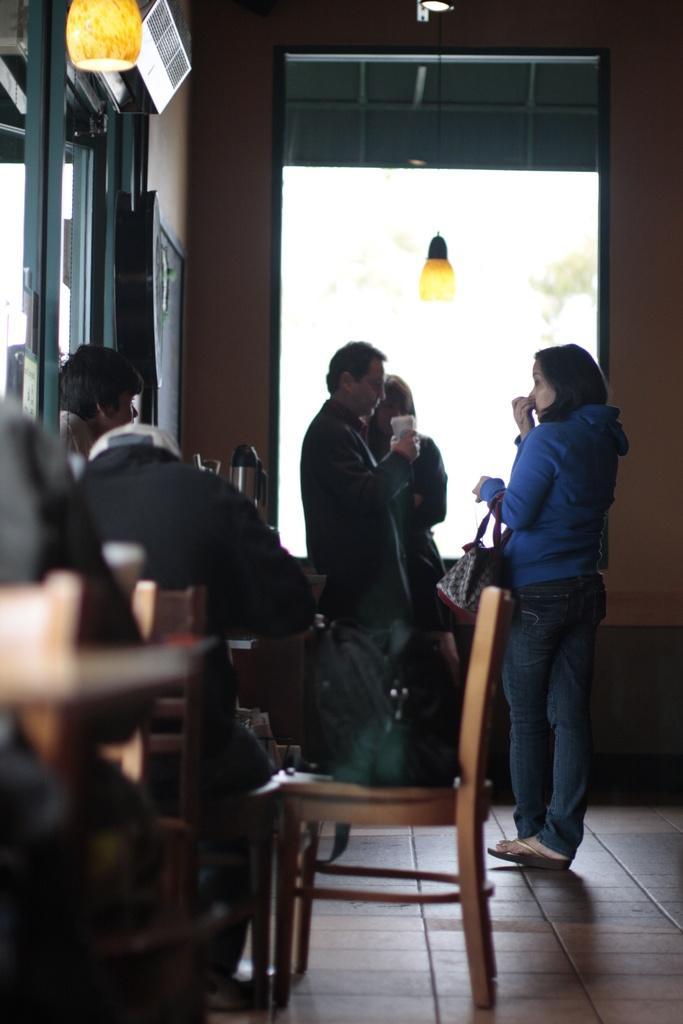Describe this image in one or two sentences. In this picture we can see three people standing near the window and the other person is looking at them and there is a chair and a backpack on it and also lamps to the roof. 